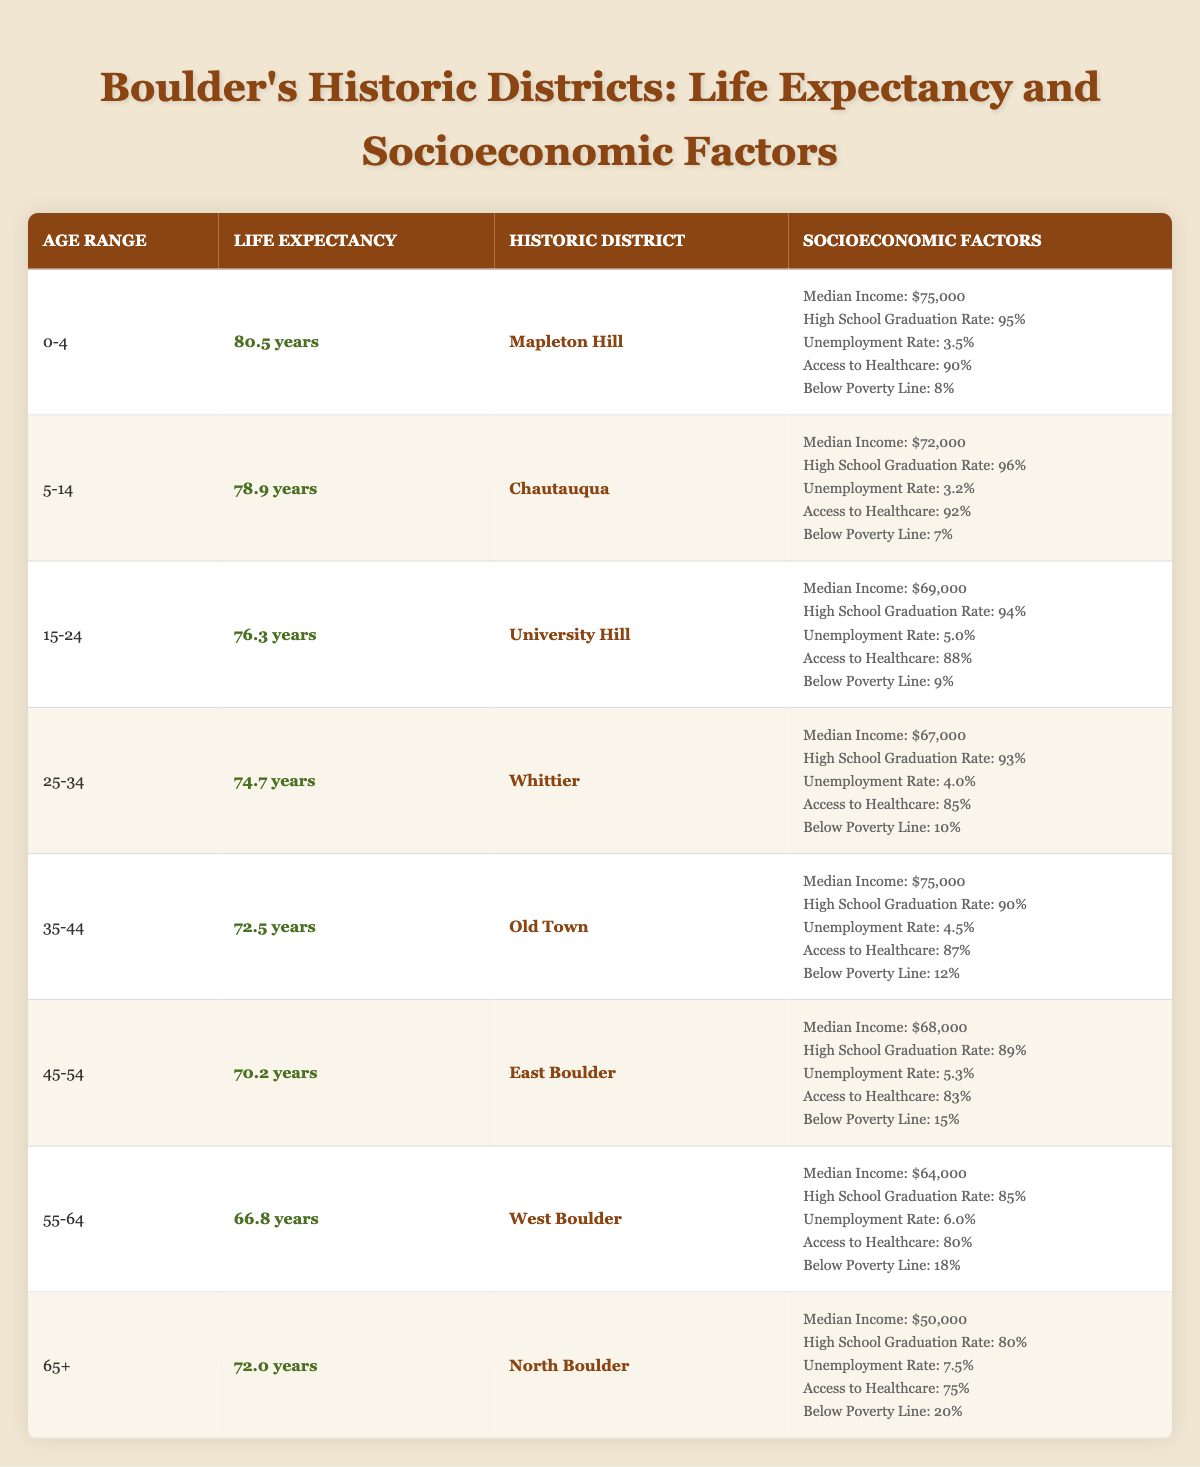What is the life expectancy for the age group 55-64 in West Boulder? The table indicates that for the age group 55-64, West Boulder has a life expectancy of 66.8 years.
Answer: 66.8 years Which historic district has the highest life expectancy for the age group 0-4? Looking at the table, Mapleton Hill has the highest life expectancy for the age group 0-4 at 80.5 years.
Answer: Mapleton Hill What is the average unemployment rate across all age groups? The unemployment rates for the age groups are as follows: 3.5, 3.2, 5.0, 4.0, 4.5, 5.3, 6.0, and 7.5. Adding these values gives 39.0, and dividing by the number of age groups (8) gives an average unemployment rate of 39.0 / 8 = 4.875.
Answer: 4.875% Is the median income in the East Boulder district above $75,000? The table shows that the median income in the East Boulder district is $68,000, which is below $75,000.
Answer: No How many districts have a high school graduation rate of 90% or higher? The districts with high school graduation rates of 90% or higher are Mapleton Hill (95%), Chautauqua (96%), University Hill (94%), and Old Town (90%). That counts to four districts.
Answer: 4 districts What is the life expectancy difference between the age groups 25-34 and 45-54? The life expectancy for age group 25-34 in Whittier is 74.7 years, while for age group 45-54 in East Boulder, it is 70.2 years. The difference is 74.7 - 70.2 = 4.5 years.
Answer: 4.5 years Is there a correlation between access to healthcare and life expectancy in the data provided? By analyzing the table, it's noted that higher life expectancy is generally associated with higher access to healthcare percentages. For instance, Mapleton Hill has the highest life expectancy (80.5) and access (90%), while North Boulder has a lower life expectancy (72.0) with lower access (75%). This suggests a positive correlation.
Answer: Yes Which age group has the highest percentage of people below the poverty line? The age group 65+ in North Boulder has the highest percentage below the poverty line at 20%.
Answer: 20% (65+ age group) In which historic district is the unemployment rate the lowest, and what is that rate? The lowest unemployment rate is 3.2% in Chautauqua.
Answer: 3.2% (Chautauqua) 